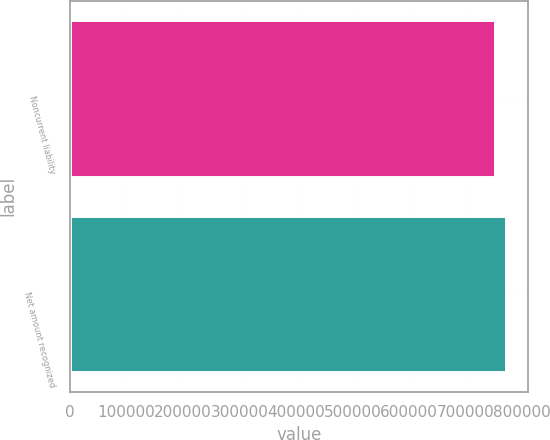Convert chart. <chart><loc_0><loc_0><loc_500><loc_500><bar_chart><fcel>Noncurrent liability<fcel>Net amount recognized<nl><fcel>752558<fcel>771665<nl></chart> 